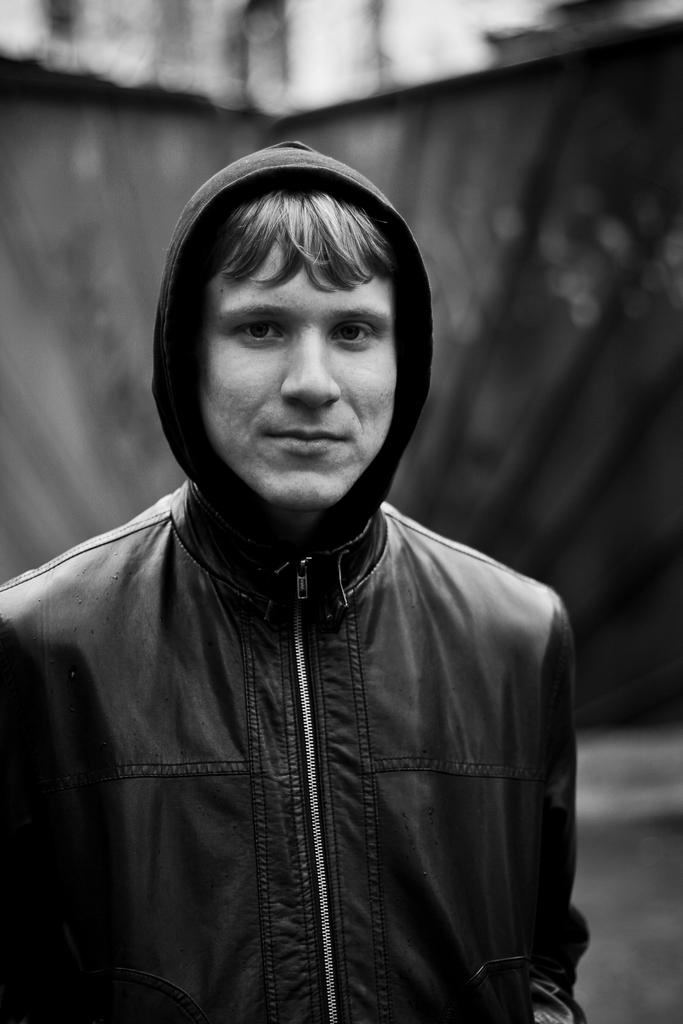What is the color scheme of the image? The image is black and white. Can you describe the main subject in the image? There is a person in the image. What can be observed about the background of the image? The background of the image is blurred. What type of truck can be seen in the background of the image? There is no truck visible in the image, as it is black and white and only features a person with a blurred background. 